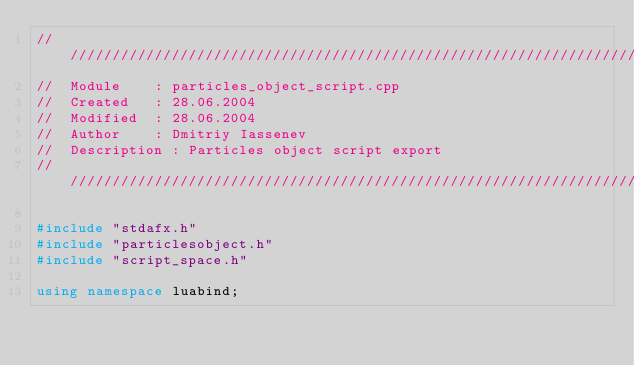<code> <loc_0><loc_0><loc_500><loc_500><_C++_>////////////////////////////////////////////////////////////////////////////
//	Module 		: particles_object_script.cpp
//	Created 	: 28.06.2004
//  Modified 	: 28.06.2004
//	Author		: Dmitriy Iassenev
//	Description : Particles object script export
////////////////////////////////////////////////////////////////////////////

#include "stdafx.h"
#include "particlesobject.h"
#include "script_space.h"

using namespace luabind;

</code> 